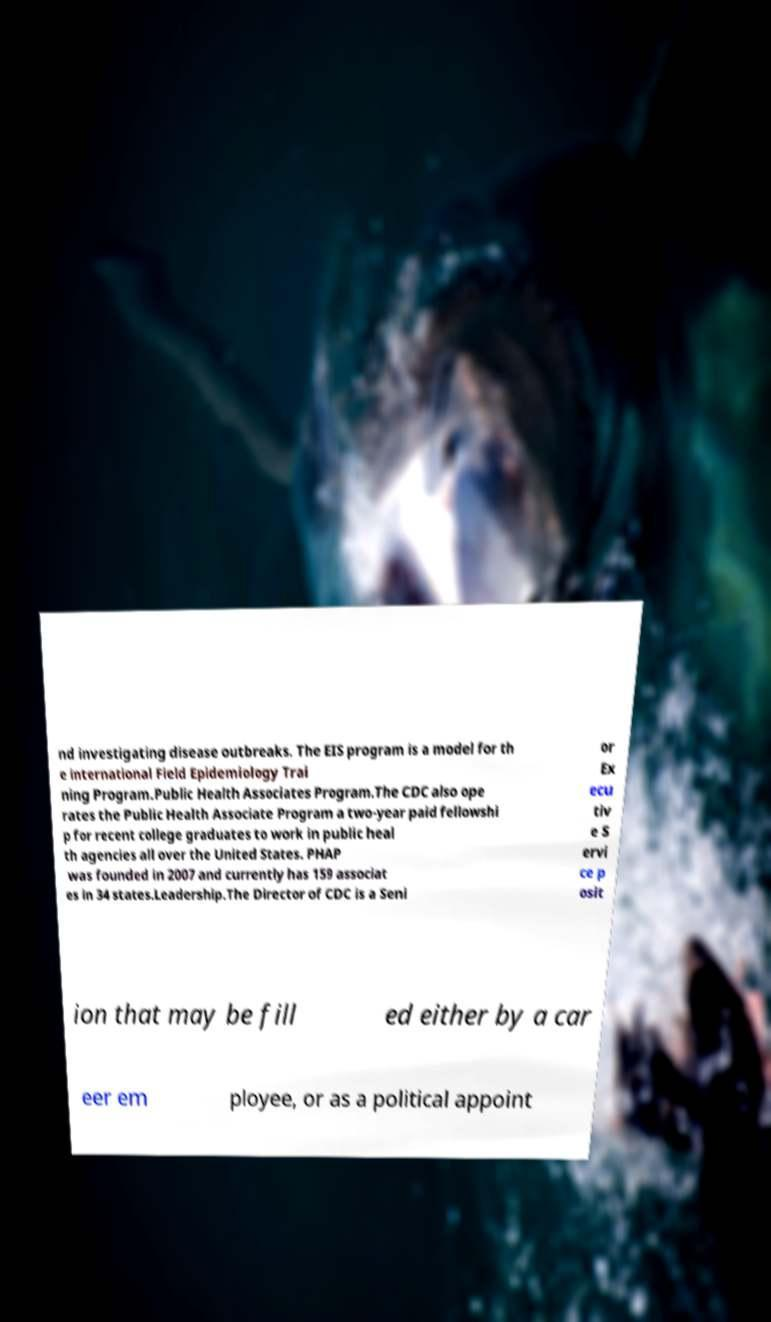For documentation purposes, I need the text within this image transcribed. Could you provide that? nd investigating disease outbreaks. The EIS program is a model for th e international Field Epidemiology Trai ning Program.Public Health Associates Program.The CDC also ope rates the Public Health Associate Program a two-year paid fellowshi p for recent college graduates to work in public heal th agencies all over the United States. PHAP was founded in 2007 and currently has 159 associat es in 34 states.Leadership.The Director of CDC is a Seni or Ex ecu tiv e S ervi ce p osit ion that may be fill ed either by a car eer em ployee, or as a political appoint 